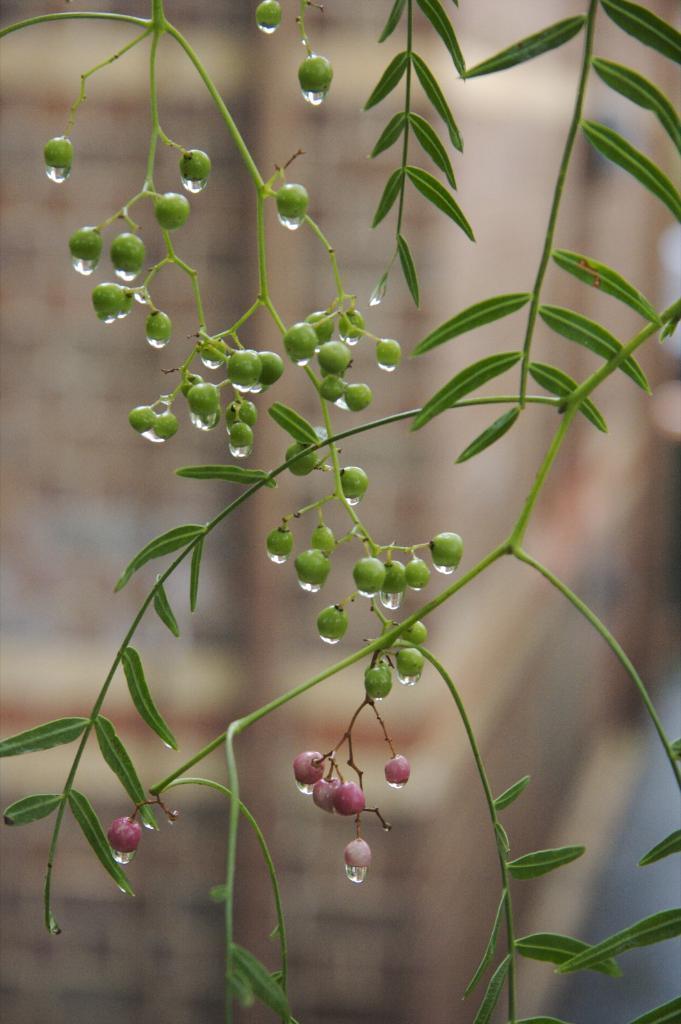How would you summarize this image in a sentence or two? In this image in the foreground there are some leaves and some fruits, and the background is blurred. 